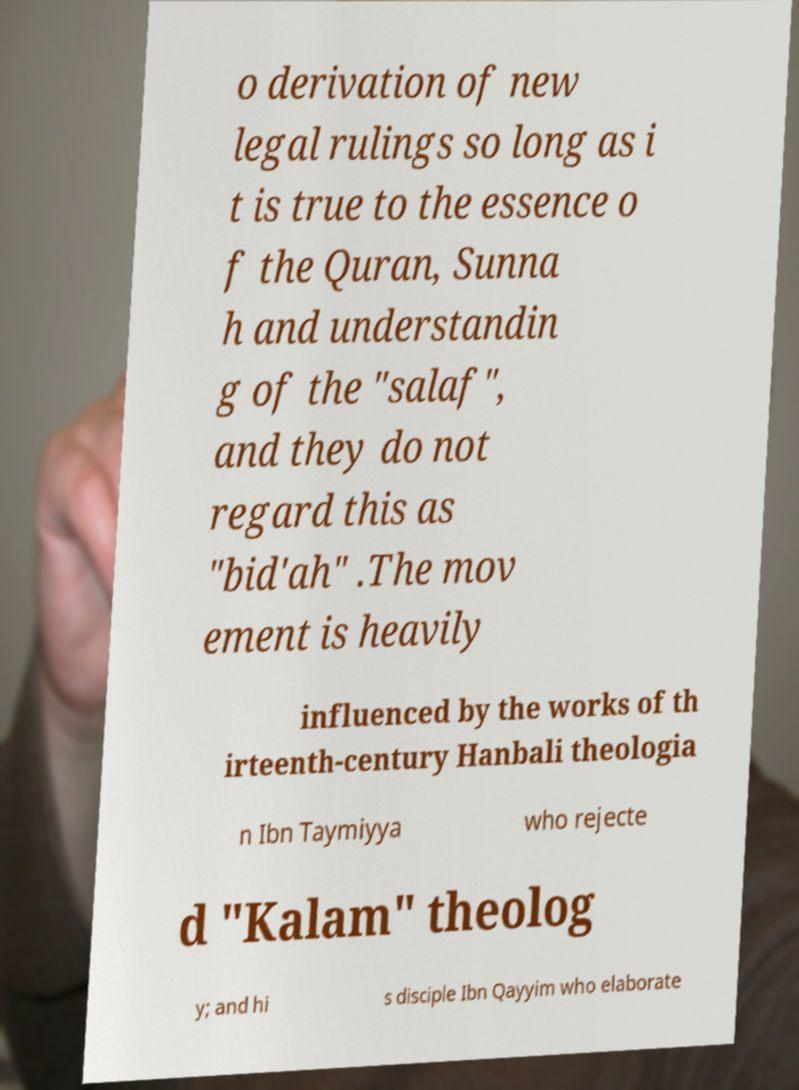Can you read and provide the text displayed in the image?This photo seems to have some interesting text. Can you extract and type it out for me? o derivation of new legal rulings so long as i t is true to the essence o f the Quran, Sunna h and understandin g of the "salaf", and they do not regard this as "bid'ah" .The mov ement is heavily influenced by the works of th irteenth-century Hanbali theologia n Ibn Taymiyya who rejecte d "Kalam" theolog y; and hi s disciple Ibn Qayyim who elaborate 